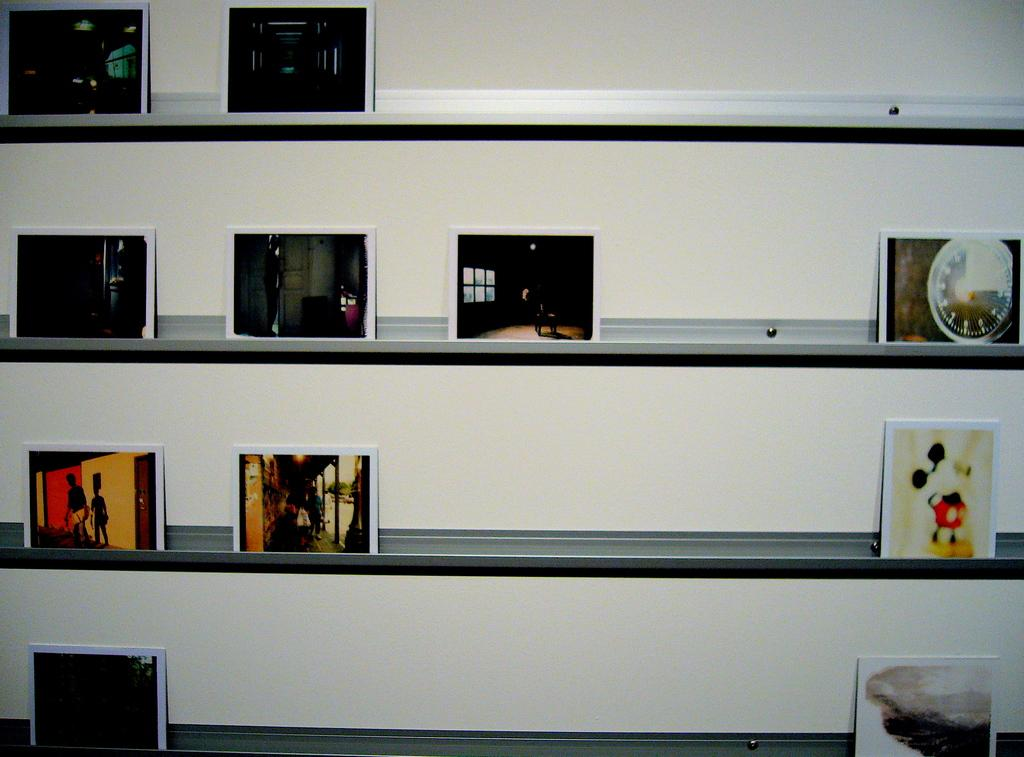What is attached to the wall in the image? There are racks attached to the wall in the image. Where are the racks located in the image? The racks are in the middle of the image. What can be seen on each of the racks? There are photo frames on each of the racks. How many noses can be seen on the photo frames in the image? There are no noses visible in the image; the photo frames contain images or artwork, not body parts. 